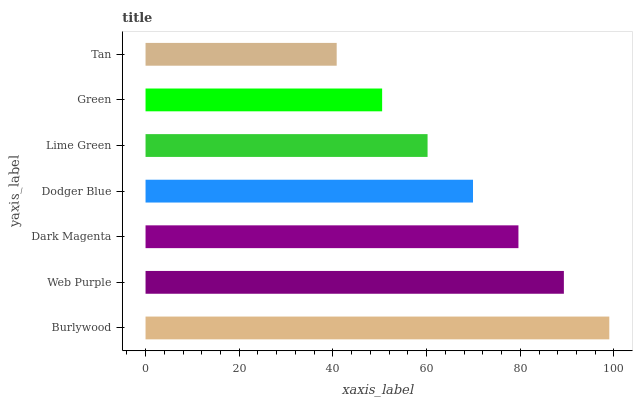Is Tan the minimum?
Answer yes or no. Yes. Is Burlywood the maximum?
Answer yes or no. Yes. Is Web Purple the minimum?
Answer yes or no. No. Is Web Purple the maximum?
Answer yes or no. No. Is Burlywood greater than Web Purple?
Answer yes or no. Yes. Is Web Purple less than Burlywood?
Answer yes or no. Yes. Is Web Purple greater than Burlywood?
Answer yes or no. No. Is Burlywood less than Web Purple?
Answer yes or no. No. Is Dodger Blue the high median?
Answer yes or no. Yes. Is Dodger Blue the low median?
Answer yes or no. Yes. Is Green the high median?
Answer yes or no. No. Is Web Purple the low median?
Answer yes or no. No. 